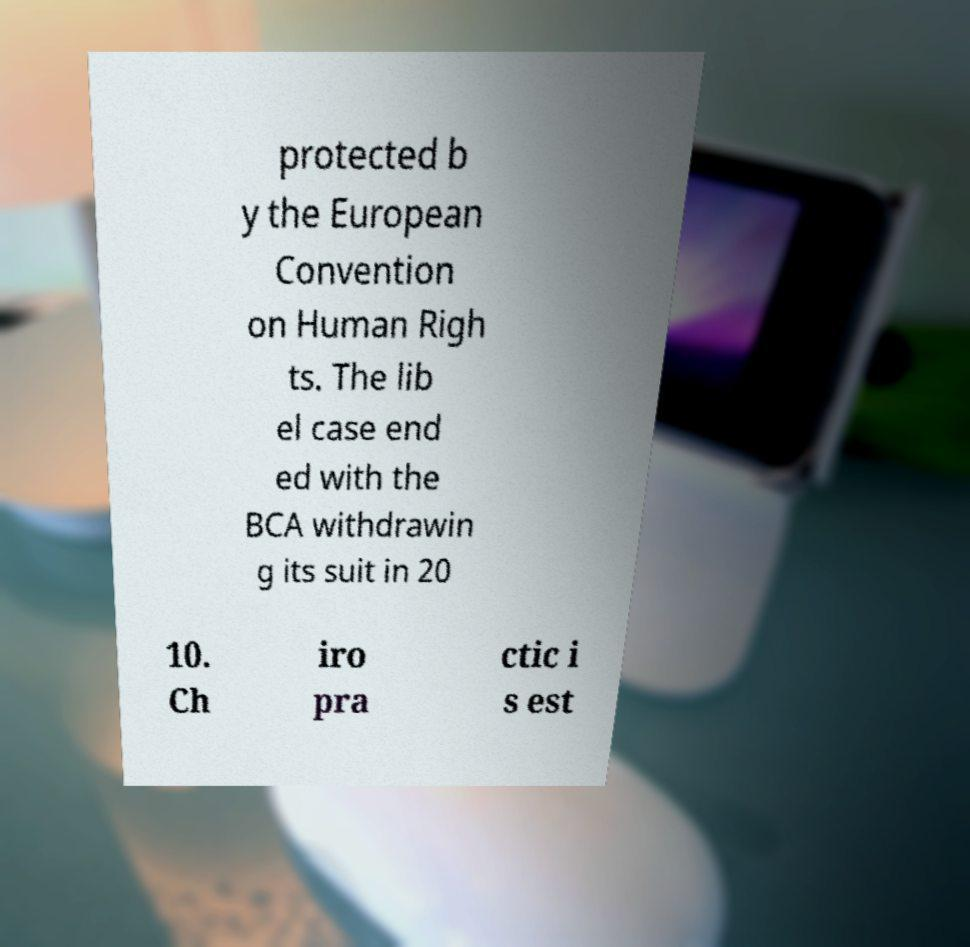Please read and relay the text visible in this image. What does it say? protected b y the European Convention on Human Righ ts. The lib el case end ed with the BCA withdrawin g its suit in 20 10. Ch iro pra ctic i s est 